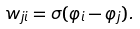Convert formula to latex. <formula><loc_0><loc_0><loc_500><loc_500>w _ { j i } = \sigma ( \varphi _ { i } - \varphi _ { j } ) .</formula> 